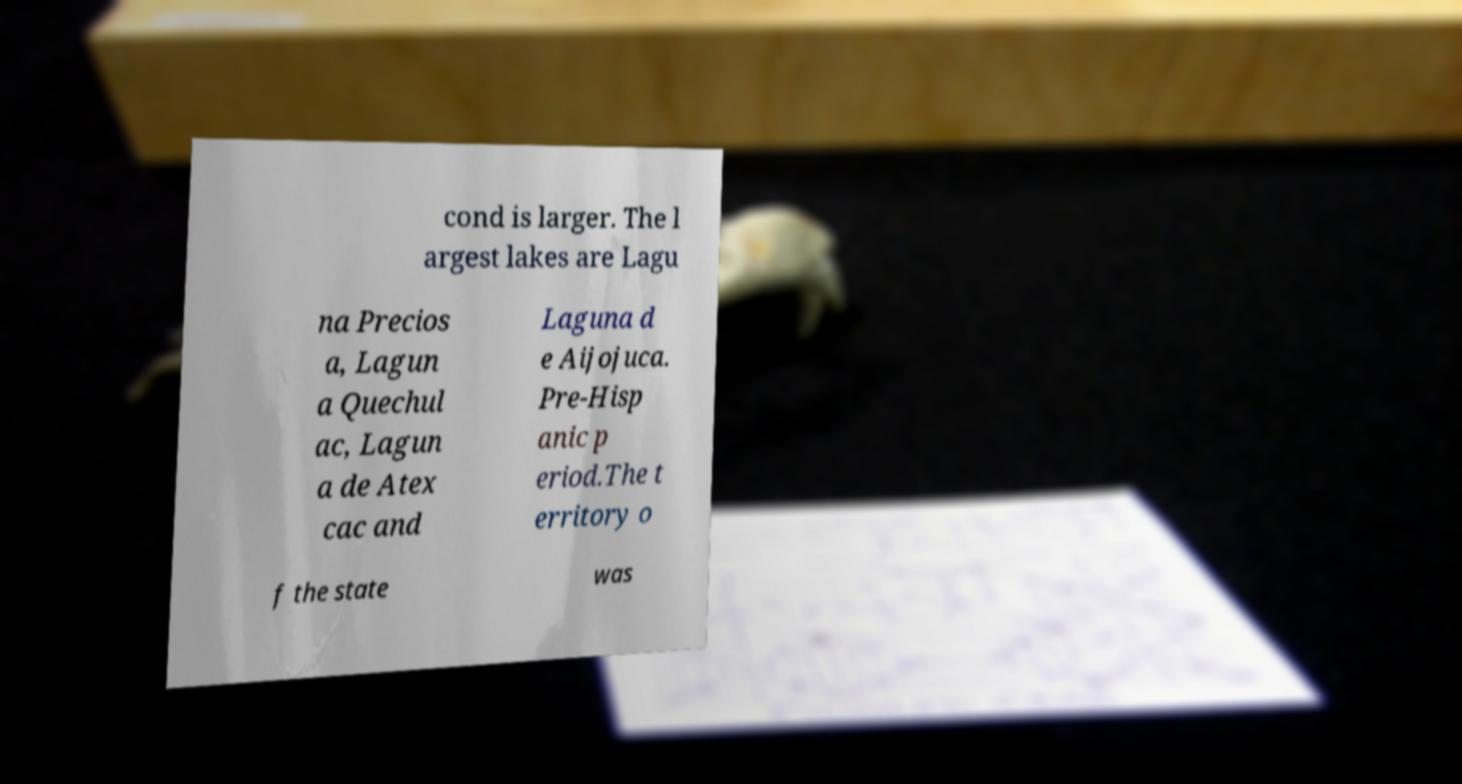Could you assist in decoding the text presented in this image and type it out clearly? cond is larger. The l argest lakes are Lagu na Precios a, Lagun a Quechul ac, Lagun a de Atex cac and Laguna d e Aijojuca. Pre-Hisp anic p eriod.The t erritory o f the state was 